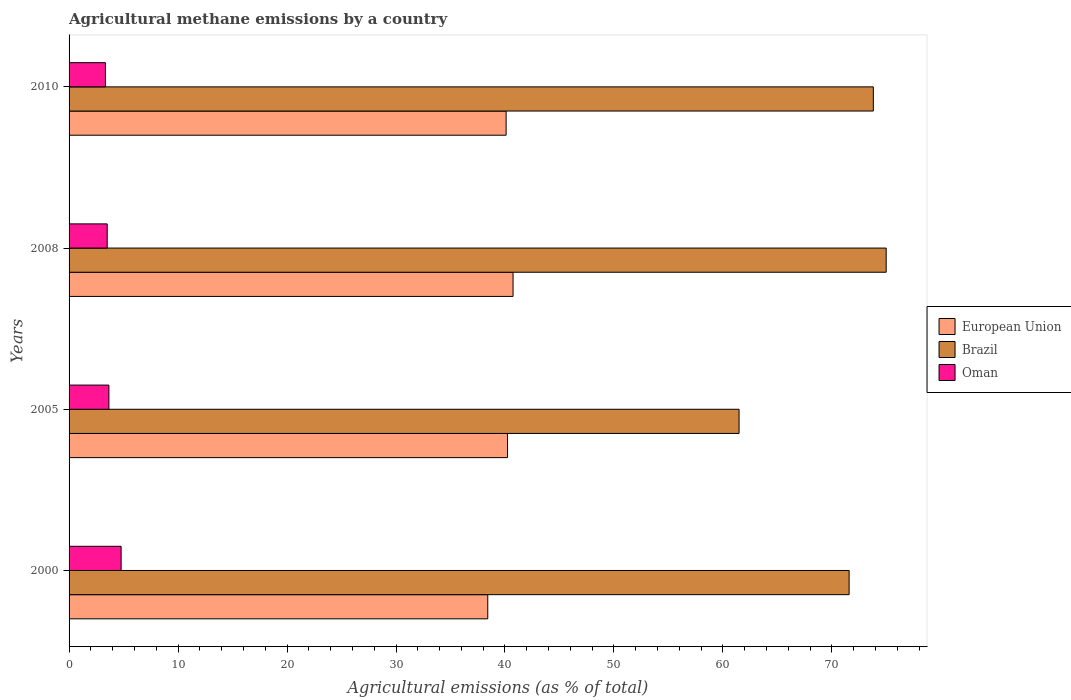Are the number of bars per tick equal to the number of legend labels?
Keep it short and to the point. Yes. Are the number of bars on each tick of the Y-axis equal?
Your response must be concise. Yes. How many bars are there on the 1st tick from the top?
Provide a succinct answer. 3. What is the amount of agricultural methane emitted in Brazil in 2005?
Offer a very short reply. 61.48. Across all years, what is the maximum amount of agricultural methane emitted in Oman?
Your answer should be compact. 4.78. Across all years, what is the minimum amount of agricultural methane emitted in Oman?
Keep it short and to the point. 3.34. What is the total amount of agricultural methane emitted in Oman in the graph?
Your answer should be compact. 15.27. What is the difference between the amount of agricultural methane emitted in Brazil in 2000 and that in 2010?
Keep it short and to the point. -2.22. What is the difference between the amount of agricultural methane emitted in European Union in 2010 and the amount of agricultural methane emitted in Brazil in 2000?
Give a very brief answer. -31.48. What is the average amount of agricultural methane emitted in Brazil per year?
Provide a succinct answer. 70.46. In the year 2008, what is the difference between the amount of agricultural methane emitted in European Union and amount of agricultural methane emitted in Oman?
Offer a terse response. 37.24. What is the ratio of the amount of agricultural methane emitted in European Union in 2000 to that in 2010?
Keep it short and to the point. 0.96. Is the amount of agricultural methane emitted in Oman in 2000 less than that in 2005?
Your answer should be very brief. No. What is the difference between the highest and the second highest amount of agricultural methane emitted in Oman?
Provide a short and direct response. 1.12. What is the difference between the highest and the lowest amount of agricultural methane emitted in Oman?
Ensure brevity in your answer.  1.44. In how many years, is the amount of agricultural methane emitted in Oman greater than the average amount of agricultural methane emitted in Oman taken over all years?
Provide a succinct answer. 1. Is the sum of the amount of agricultural methane emitted in Brazil in 2008 and 2010 greater than the maximum amount of agricultural methane emitted in European Union across all years?
Give a very brief answer. Yes. What does the 3rd bar from the top in 2000 represents?
Provide a succinct answer. European Union. How many bars are there?
Keep it short and to the point. 12. How many years are there in the graph?
Your response must be concise. 4. Are the values on the major ticks of X-axis written in scientific E-notation?
Ensure brevity in your answer.  No. Where does the legend appear in the graph?
Offer a very short reply. Center right. How many legend labels are there?
Offer a very short reply. 3. How are the legend labels stacked?
Make the answer very short. Vertical. What is the title of the graph?
Your answer should be very brief. Agricultural methane emissions by a country. Does "Bangladesh" appear as one of the legend labels in the graph?
Your answer should be compact. No. What is the label or title of the X-axis?
Ensure brevity in your answer.  Agricultural emissions (as % of total). What is the label or title of the Y-axis?
Offer a very short reply. Years. What is the Agricultural emissions (as % of total) in European Union in 2000?
Ensure brevity in your answer.  38.42. What is the Agricultural emissions (as % of total) of Brazil in 2000?
Give a very brief answer. 71.58. What is the Agricultural emissions (as % of total) in Oman in 2000?
Provide a short and direct response. 4.78. What is the Agricultural emissions (as % of total) of European Union in 2005?
Give a very brief answer. 40.24. What is the Agricultural emissions (as % of total) in Brazil in 2005?
Make the answer very short. 61.48. What is the Agricultural emissions (as % of total) in Oman in 2005?
Offer a terse response. 3.66. What is the Agricultural emissions (as % of total) of European Union in 2008?
Ensure brevity in your answer.  40.74. What is the Agricultural emissions (as % of total) in Brazil in 2008?
Offer a very short reply. 74.98. What is the Agricultural emissions (as % of total) of Oman in 2008?
Your response must be concise. 3.5. What is the Agricultural emissions (as % of total) in European Union in 2010?
Provide a succinct answer. 40.11. What is the Agricultural emissions (as % of total) in Brazil in 2010?
Provide a short and direct response. 73.8. What is the Agricultural emissions (as % of total) of Oman in 2010?
Provide a succinct answer. 3.34. Across all years, what is the maximum Agricultural emissions (as % of total) in European Union?
Your answer should be compact. 40.74. Across all years, what is the maximum Agricultural emissions (as % of total) in Brazil?
Provide a short and direct response. 74.98. Across all years, what is the maximum Agricultural emissions (as % of total) in Oman?
Your answer should be compact. 4.78. Across all years, what is the minimum Agricultural emissions (as % of total) in European Union?
Your answer should be very brief. 38.42. Across all years, what is the minimum Agricultural emissions (as % of total) of Brazil?
Your response must be concise. 61.48. Across all years, what is the minimum Agricultural emissions (as % of total) of Oman?
Provide a succinct answer. 3.34. What is the total Agricultural emissions (as % of total) in European Union in the graph?
Offer a terse response. 159.5. What is the total Agricultural emissions (as % of total) of Brazil in the graph?
Give a very brief answer. 281.85. What is the total Agricultural emissions (as % of total) of Oman in the graph?
Your answer should be compact. 15.27. What is the difference between the Agricultural emissions (as % of total) of European Union in 2000 and that in 2005?
Give a very brief answer. -1.81. What is the difference between the Agricultural emissions (as % of total) of Brazil in 2000 and that in 2005?
Keep it short and to the point. 10.1. What is the difference between the Agricultural emissions (as % of total) of Oman in 2000 and that in 2005?
Your answer should be compact. 1.12. What is the difference between the Agricultural emissions (as % of total) in European Union in 2000 and that in 2008?
Keep it short and to the point. -2.32. What is the difference between the Agricultural emissions (as % of total) of Brazil in 2000 and that in 2008?
Make the answer very short. -3.4. What is the difference between the Agricultural emissions (as % of total) in Oman in 2000 and that in 2008?
Make the answer very short. 1.28. What is the difference between the Agricultural emissions (as % of total) of European Union in 2000 and that in 2010?
Your answer should be very brief. -1.68. What is the difference between the Agricultural emissions (as % of total) in Brazil in 2000 and that in 2010?
Your answer should be compact. -2.22. What is the difference between the Agricultural emissions (as % of total) in Oman in 2000 and that in 2010?
Your answer should be compact. 1.44. What is the difference between the Agricultural emissions (as % of total) of European Union in 2005 and that in 2008?
Provide a succinct answer. -0.51. What is the difference between the Agricultural emissions (as % of total) in Brazil in 2005 and that in 2008?
Provide a short and direct response. -13.5. What is the difference between the Agricultural emissions (as % of total) in Oman in 2005 and that in 2008?
Ensure brevity in your answer.  0.16. What is the difference between the Agricultural emissions (as % of total) of European Union in 2005 and that in 2010?
Offer a terse response. 0.13. What is the difference between the Agricultural emissions (as % of total) in Brazil in 2005 and that in 2010?
Provide a succinct answer. -12.32. What is the difference between the Agricultural emissions (as % of total) of Oman in 2005 and that in 2010?
Your answer should be very brief. 0.32. What is the difference between the Agricultural emissions (as % of total) of European Union in 2008 and that in 2010?
Give a very brief answer. 0.64. What is the difference between the Agricultural emissions (as % of total) in Brazil in 2008 and that in 2010?
Provide a short and direct response. 1.18. What is the difference between the Agricultural emissions (as % of total) in Oman in 2008 and that in 2010?
Your answer should be compact. 0.16. What is the difference between the Agricultural emissions (as % of total) in European Union in 2000 and the Agricultural emissions (as % of total) in Brazil in 2005?
Ensure brevity in your answer.  -23.06. What is the difference between the Agricultural emissions (as % of total) in European Union in 2000 and the Agricultural emissions (as % of total) in Oman in 2005?
Keep it short and to the point. 34.77. What is the difference between the Agricultural emissions (as % of total) in Brazil in 2000 and the Agricultural emissions (as % of total) in Oman in 2005?
Your response must be concise. 67.93. What is the difference between the Agricultural emissions (as % of total) of European Union in 2000 and the Agricultural emissions (as % of total) of Brazil in 2008?
Your answer should be very brief. -36.56. What is the difference between the Agricultural emissions (as % of total) of European Union in 2000 and the Agricultural emissions (as % of total) of Oman in 2008?
Your answer should be compact. 34.92. What is the difference between the Agricultural emissions (as % of total) of Brazil in 2000 and the Agricultural emissions (as % of total) of Oman in 2008?
Keep it short and to the point. 68.08. What is the difference between the Agricultural emissions (as % of total) in European Union in 2000 and the Agricultural emissions (as % of total) in Brazil in 2010?
Your response must be concise. -35.38. What is the difference between the Agricultural emissions (as % of total) in European Union in 2000 and the Agricultural emissions (as % of total) in Oman in 2010?
Make the answer very short. 35.08. What is the difference between the Agricultural emissions (as % of total) of Brazil in 2000 and the Agricultural emissions (as % of total) of Oman in 2010?
Your response must be concise. 68.24. What is the difference between the Agricultural emissions (as % of total) of European Union in 2005 and the Agricultural emissions (as % of total) of Brazil in 2008?
Your answer should be compact. -34.75. What is the difference between the Agricultural emissions (as % of total) of European Union in 2005 and the Agricultural emissions (as % of total) of Oman in 2008?
Ensure brevity in your answer.  36.74. What is the difference between the Agricultural emissions (as % of total) of Brazil in 2005 and the Agricultural emissions (as % of total) of Oman in 2008?
Provide a succinct answer. 57.98. What is the difference between the Agricultural emissions (as % of total) in European Union in 2005 and the Agricultural emissions (as % of total) in Brazil in 2010?
Provide a succinct answer. -33.57. What is the difference between the Agricultural emissions (as % of total) of European Union in 2005 and the Agricultural emissions (as % of total) of Oman in 2010?
Your answer should be very brief. 36.9. What is the difference between the Agricultural emissions (as % of total) of Brazil in 2005 and the Agricultural emissions (as % of total) of Oman in 2010?
Keep it short and to the point. 58.15. What is the difference between the Agricultural emissions (as % of total) of European Union in 2008 and the Agricultural emissions (as % of total) of Brazil in 2010?
Your response must be concise. -33.06. What is the difference between the Agricultural emissions (as % of total) of European Union in 2008 and the Agricultural emissions (as % of total) of Oman in 2010?
Give a very brief answer. 37.4. What is the difference between the Agricultural emissions (as % of total) in Brazil in 2008 and the Agricultural emissions (as % of total) in Oman in 2010?
Make the answer very short. 71.64. What is the average Agricultural emissions (as % of total) in European Union per year?
Your answer should be very brief. 39.88. What is the average Agricultural emissions (as % of total) of Brazil per year?
Ensure brevity in your answer.  70.46. What is the average Agricultural emissions (as % of total) of Oman per year?
Offer a terse response. 3.82. In the year 2000, what is the difference between the Agricultural emissions (as % of total) in European Union and Agricultural emissions (as % of total) in Brazil?
Your answer should be very brief. -33.16. In the year 2000, what is the difference between the Agricultural emissions (as % of total) in European Union and Agricultural emissions (as % of total) in Oman?
Offer a very short reply. 33.65. In the year 2000, what is the difference between the Agricultural emissions (as % of total) of Brazil and Agricultural emissions (as % of total) of Oman?
Your response must be concise. 66.81. In the year 2005, what is the difference between the Agricultural emissions (as % of total) of European Union and Agricultural emissions (as % of total) of Brazil?
Your answer should be very brief. -21.25. In the year 2005, what is the difference between the Agricultural emissions (as % of total) of European Union and Agricultural emissions (as % of total) of Oman?
Provide a succinct answer. 36.58. In the year 2005, what is the difference between the Agricultural emissions (as % of total) in Brazil and Agricultural emissions (as % of total) in Oman?
Provide a succinct answer. 57.83. In the year 2008, what is the difference between the Agricultural emissions (as % of total) in European Union and Agricultural emissions (as % of total) in Brazil?
Make the answer very short. -34.24. In the year 2008, what is the difference between the Agricultural emissions (as % of total) of European Union and Agricultural emissions (as % of total) of Oman?
Your answer should be compact. 37.24. In the year 2008, what is the difference between the Agricultural emissions (as % of total) in Brazil and Agricultural emissions (as % of total) in Oman?
Keep it short and to the point. 71.48. In the year 2010, what is the difference between the Agricultural emissions (as % of total) of European Union and Agricultural emissions (as % of total) of Brazil?
Make the answer very short. -33.7. In the year 2010, what is the difference between the Agricultural emissions (as % of total) in European Union and Agricultural emissions (as % of total) in Oman?
Provide a short and direct response. 36.77. In the year 2010, what is the difference between the Agricultural emissions (as % of total) in Brazil and Agricultural emissions (as % of total) in Oman?
Your answer should be very brief. 70.47. What is the ratio of the Agricultural emissions (as % of total) in European Union in 2000 to that in 2005?
Ensure brevity in your answer.  0.95. What is the ratio of the Agricultural emissions (as % of total) of Brazil in 2000 to that in 2005?
Your answer should be very brief. 1.16. What is the ratio of the Agricultural emissions (as % of total) in Oman in 2000 to that in 2005?
Offer a very short reply. 1.31. What is the ratio of the Agricultural emissions (as % of total) of European Union in 2000 to that in 2008?
Ensure brevity in your answer.  0.94. What is the ratio of the Agricultural emissions (as % of total) of Brazil in 2000 to that in 2008?
Provide a succinct answer. 0.95. What is the ratio of the Agricultural emissions (as % of total) in Oman in 2000 to that in 2008?
Offer a terse response. 1.36. What is the ratio of the Agricultural emissions (as % of total) of European Union in 2000 to that in 2010?
Make the answer very short. 0.96. What is the ratio of the Agricultural emissions (as % of total) in Brazil in 2000 to that in 2010?
Provide a short and direct response. 0.97. What is the ratio of the Agricultural emissions (as % of total) in Oman in 2000 to that in 2010?
Provide a short and direct response. 1.43. What is the ratio of the Agricultural emissions (as % of total) of European Union in 2005 to that in 2008?
Give a very brief answer. 0.99. What is the ratio of the Agricultural emissions (as % of total) in Brazil in 2005 to that in 2008?
Provide a short and direct response. 0.82. What is the ratio of the Agricultural emissions (as % of total) in Oman in 2005 to that in 2008?
Make the answer very short. 1.04. What is the ratio of the Agricultural emissions (as % of total) in Brazil in 2005 to that in 2010?
Provide a succinct answer. 0.83. What is the ratio of the Agricultural emissions (as % of total) in Oman in 2005 to that in 2010?
Offer a terse response. 1.09. What is the ratio of the Agricultural emissions (as % of total) in European Union in 2008 to that in 2010?
Give a very brief answer. 1.02. What is the ratio of the Agricultural emissions (as % of total) of Brazil in 2008 to that in 2010?
Offer a very short reply. 1.02. What is the ratio of the Agricultural emissions (as % of total) of Oman in 2008 to that in 2010?
Your response must be concise. 1.05. What is the difference between the highest and the second highest Agricultural emissions (as % of total) of European Union?
Keep it short and to the point. 0.51. What is the difference between the highest and the second highest Agricultural emissions (as % of total) of Brazil?
Your response must be concise. 1.18. What is the difference between the highest and the second highest Agricultural emissions (as % of total) in Oman?
Keep it short and to the point. 1.12. What is the difference between the highest and the lowest Agricultural emissions (as % of total) in European Union?
Provide a succinct answer. 2.32. What is the difference between the highest and the lowest Agricultural emissions (as % of total) of Brazil?
Provide a short and direct response. 13.5. What is the difference between the highest and the lowest Agricultural emissions (as % of total) in Oman?
Your answer should be compact. 1.44. 